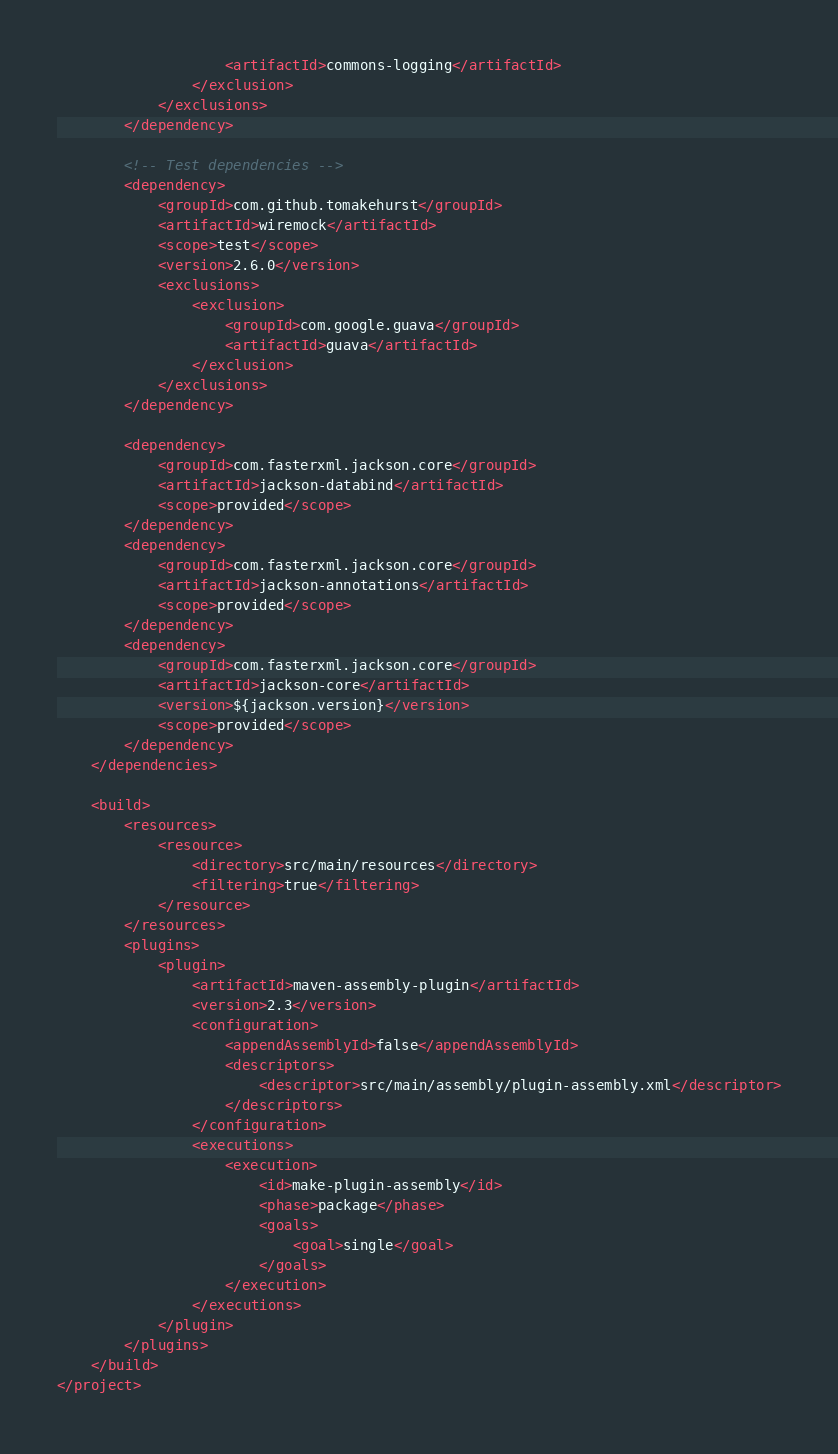Convert code to text. <code><loc_0><loc_0><loc_500><loc_500><_XML_>                    <artifactId>commons-logging</artifactId>
                </exclusion>
            </exclusions>
        </dependency>

        <!-- Test dependencies -->
        <dependency>
            <groupId>com.github.tomakehurst</groupId>
            <artifactId>wiremock</artifactId>
            <scope>test</scope>
            <version>2.6.0</version>
            <exclusions>
                <exclusion>
                    <groupId>com.google.guava</groupId>
                    <artifactId>guava</artifactId>
                </exclusion>
            </exclusions>
        </dependency>

        <dependency>
            <groupId>com.fasterxml.jackson.core</groupId>
            <artifactId>jackson-databind</artifactId>
            <scope>provided</scope>
        </dependency>
        <dependency>
            <groupId>com.fasterxml.jackson.core</groupId>
            <artifactId>jackson-annotations</artifactId>
            <scope>provided</scope>
        </dependency>
        <dependency>
            <groupId>com.fasterxml.jackson.core</groupId>
            <artifactId>jackson-core</artifactId>
            <version>${jackson.version}</version>
            <scope>provided</scope>
        </dependency>
    </dependencies>

    <build>
        <resources>
            <resource>
                <directory>src/main/resources</directory>
                <filtering>true</filtering>
            </resource>
        </resources>
        <plugins>
            <plugin>
                <artifactId>maven-assembly-plugin</artifactId>
                <version>2.3</version>
                <configuration>
                    <appendAssemblyId>false</appendAssemblyId>
                    <descriptors>
                        <descriptor>src/main/assembly/plugin-assembly.xml</descriptor>
                    </descriptors>
                </configuration>
                <executions>
                    <execution>
                        <id>make-plugin-assembly</id>
                        <phase>package</phase>
                        <goals>
                            <goal>single</goal>
                        </goals>
                    </execution>
                </executions>
            </plugin>
        </plugins>
    </build>
</project>
</code> 